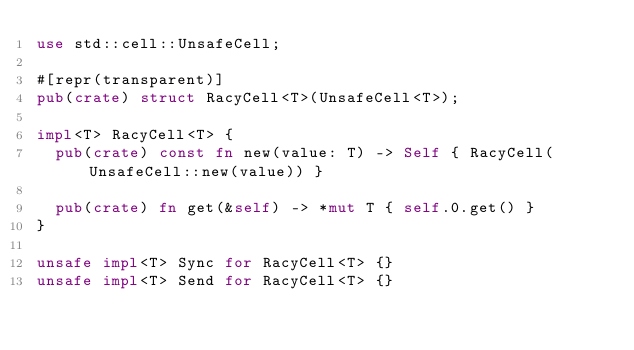Convert code to text. <code><loc_0><loc_0><loc_500><loc_500><_Rust_>use std::cell::UnsafeCell;

#[repr(transparent)]
pub(crate) struct RacyCell<T>(UnsafeCell<T>);

impl<T> RacyCell<T> {
	pub(crate) const fn new(value: T) -> Self { RacyCell(UnsafeCell::new(value)) }

	pub(crate) fn get(&self) -> *mut T { self.0.get() }
}

unsafe impl<T> Sync for RacyCell<T> {}
unsafe impl<T> Send for RacyCell<T> {}
</code> 